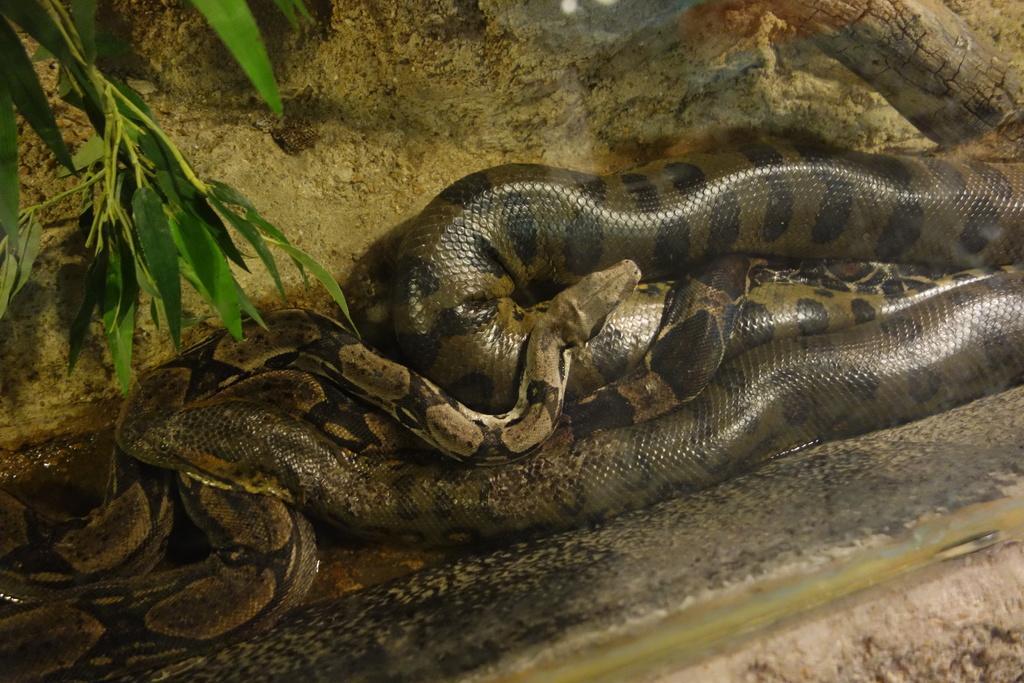Please provide a concise description of this image. In this picture we can see snakes on the ground and in the background we can see leaves. 